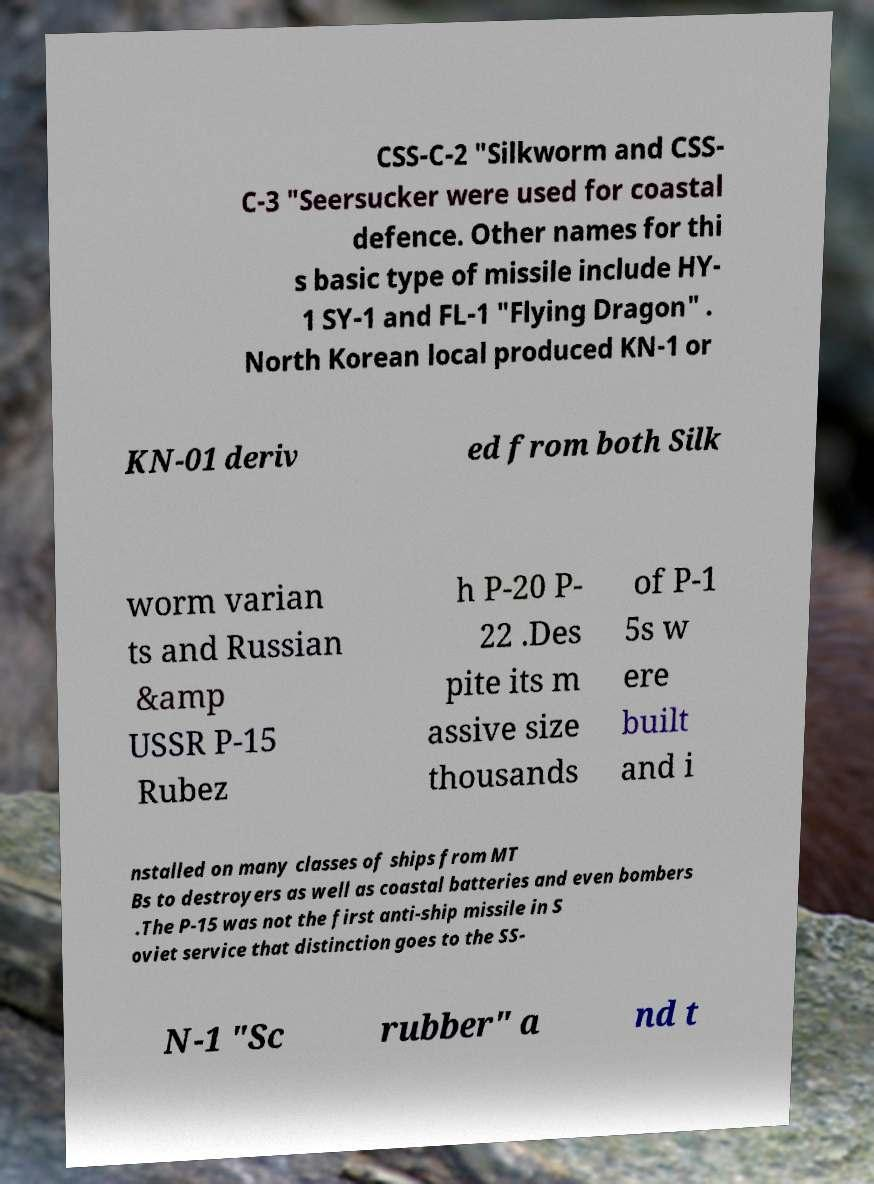There's text embedded in this image that I need extracted. Can you transcribe it verbatim? CSS-C-2 "Silkworm and CSS- C-3 "Seersucker were used for coastal defence. Other names for thi s basic type of missile include HY- 1 SY-1 and FL-1 "Flying Dragon" . North Korean local produced KN-1 or KN-01 deriv ed from both Silk worm varian ts and Russian &amp USSR P-15 Rubez h P-20 P- 22 .Des pite its m assive size thousands of P-1 5s w ere built and i nstalled on many classes of ships from MT Bs to destroyers as well as coastal batteries and even bombers .The P-15 was not the first anti-ship missile in S oviet service that distinction goes to the SS- N-1 "Sc rubber" a nd t 